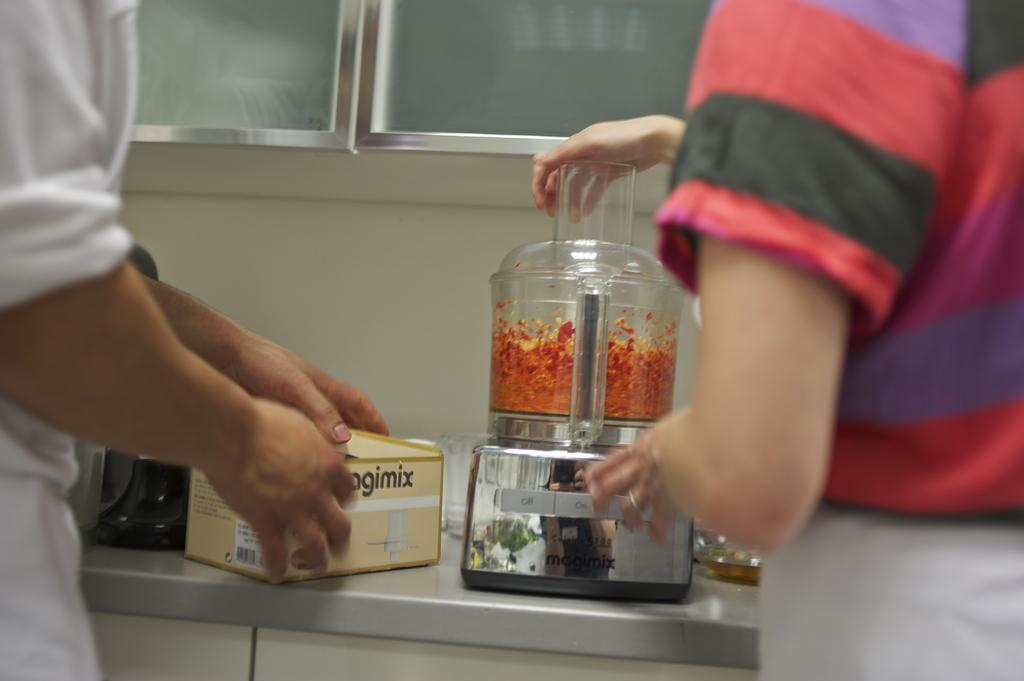<image>
Write a terse but informative summary of the picture. Two people stand at a counter, one is using a food processor while the other has the box with the partial word "agimix" seen on it. 